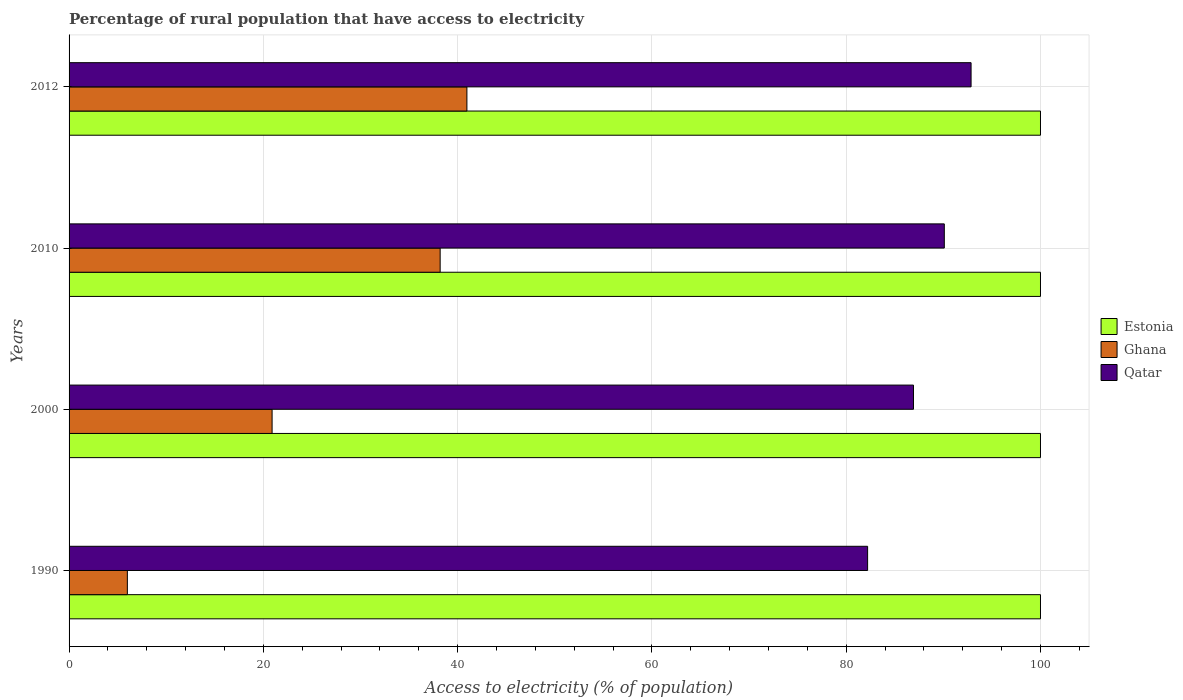How many different coloured bars are there?
Ensure brevity in your answer.  3. Are the number of bars on each tick of the Y-axis equal?
Your response must be concise. Yes. What is the percentage of rural population that have access to electricity in Ghana in 2012?
Provide a succinct answer. 40.95. Across all years, what is the maximum percentage of rural population that have access to electricity in Qatar?
Offer a very short reply. 92.85. What is the total percentage of rural population that have access to electricity in Estonia in the graph?
Offer a very short reply. 400. What is the difference between the percentage of rural population that have access to electricity in Estonia in 2010 and that in 2012?
Ensure brevity in your answer.  0. What is the difference between the percentage of rural population that have access to electricity in Ghana in 1990 and the percentage of rural population that have access to electricity in Estonia in 2000?
Your answer should be compact. -94. What is the average percentage of rural population that have access to electricity in Ghana per year?
Give a very brief answer. 26.51. In the year 1990, what is the difference between the percentage of rural population that have access to electricity in Ghana and percentage of rural population that have access to electricity in Qatar?
Your response must be concise. -76.2. In how many years, is the percentage of rural population that have access to electricity in Estonia greater than 92 %?
Ensure brevity in your answer.  4. What is the ratio of the percentage of rural population that have access to electricity in Qatar in 1990 to that in 2012?
Your answer should be compact. 0.89. Is the difference between the percentage of rural population that have access to electricity in Ghana in 1990 and 2000 greater than the difference between the percentage of rural population that have access to electricity in Qatar in 1990 and 2000?
Make the answer very short. No. What is the difference between the highest and the second highest percentage of rural population that have access to electricity in Qatar?
Keep it short and to the point. 2.75. What is the difference between the highest and the lowest percentage of rural population that have access to electricity in Qatar?
Give a very brief answer. 10.65. What does the 1st bar from the top in 2012 represents?
Your response must be concise. Qatar. What does the 1st bar from the bottom in 2010 represents?
Keep it short and to the point. Estonia. Is it the case that in every year, the sum of the percentage of rural population that have access to electricity in Estonia and percentage of rural population that have access to electricity in Ghana is greater than the percentage of rural population that have access to electricity in Qatar?
Give a very brief answer. Yes. What is the difference between two consecutive major ticks on the X-axis?
Give a very brief answer. 20. Are the values on the major ticks of X-axis written in scientific E-notation?
Provide a succinct answer. No. Does the graph contain any zero values?
Your answer should be very brief. No. Where does the legend appear in the graph?
Your response must be concise. Center right. What is the title of the graph?
Your response must be concise. Percentage of rural population that have access to electricity. Does "Isle of Man" appear as one of the legend labels in the graph?
Keep it short and to the point. No. What is the label or title of the X-axis?
Your response must be concise. Access to electricity (% of population). What is the label or title of the Y-axis?
Your answer should be very brief. Years. What is the Access to electricity (% of population) of Estonia in 1990?
Make the answer very short. 100. What is the Access to electricity (% of population) of Qatar in 1990?
Give a very brief answer. 82.2. What is the Access to electricity (% of population) in Estonia in 2000?
Give a very brief answer. 100. What is the Access to electricity (% of population) in Ghana in 2000?
Give a very brief answer. 20.9. What is the Access to electricity (% of population) in Qatar in 2000?
Your answer should be compact. 86.93. What is the Access to electricity (% of population) in Ghana in 2010?
Make the answer very short. 38.2. What is the Access to electricity (% of population) of Qatar in 2010?
Provide a succinct answer. 90.1. What is the Access to electricity (% of population) of Estonia in 2012?
Your answer should be very brief. 100. What is the Access to electricity (% of population) of Ghana in 2012?
Your answer should be compact. 40.95. What is the Access to electricity (% of population) in Qatar in 2012?
Give a very brief answer. 92.85. Across all years, what is the maximum Access to electricity (% of population) in Ghana?
Provide a short and direct response. 40.95. Across all years, what is the maximum Access to electricity (% of population) of Qatar?
Keep it short and to the point. 92.85. Across all years, what is the minimum Access to electricity (% of population) in Qatar?
Make the answer very short. 82.2. What is the total Access to electricity (% of population) in Ghana in the graph?
Offer a very short reply. 106.05. What is the total Access to electricity (% of population) in Qatar in the graph?
Offer a very short reply. 352.08. What is the difference between the Access to electricity (% of population) in Estonia in 1990 and that in 2000?
Your answer should be compact. 0. What is the difference between the Access to electricity (% of population) of Ghana in 1990 and that in 2000?
Give a very brief answer. -14.9. What is the difference between the Access to electricity (% of population) of Qatar in 1990 and that in 2000?
Offer a very short reply. -4.72. What is the difference between the Access to electricity (% of population) of Ghana in 1990 and that in 2010?
Keep it short and to the point. -32.2. What is the difference between the Access to electricity (% of population) of Qatar in 1990 and that in 2010?
Your answer should be very brief. -7.9. What is the difference between the Access to electricity (% of population) of Ghana in 1990 and that in 2012?
Ensure brevity in your answer.  -34.95. What is the difference between the Access to electricity (% of population) of Qatar in 1990 and that in 2012?
Your response must be concise. -10.65. What is the difference between the Access to electricity (% of population) of Estonia in 2000 and that in 2010?
Provide a succinct answer. 0. What is the difference between the Access to electricity (% of population) of Ghana in 2000 and that in 2010?
Provide a short and direct response. -17.3. What is the difference between the Access to electricity (% of population) in Qatar in 2000 and that in 2010?
Offer a very short reply. -3.17. What is the difference between the Access to electricity (% of population) of Estonia in 2000 and that in 2012?
Offer a very short reply. 0. What is the difference between the Access to electricity (% of population) in Ghana in 2000 and that in 2012?
Offer a terse response. -20.05. What is the difference between the Access to electricity (% of population) in Qatar in 2000 and that in 2012?
Your answer should be very brief. -5.93. What is the difference between the Access to electricity (% of population) of Estonia in 2010 and that in 2012?
Your response must be concise. 0. What is the difference between the Access to electricity (% of population) of Ghana in 2010 and that in 2012?
Your response must be concise. -2.75. What is the difference between the Access to electricity (% of population) in Qatar in 2010 and that in 2012?
Make the answer very short. -2.75. What is the difference between the Access to electricity (% of population) in Estonia in 1990 and the Access to electricity (% of population) in Ghana in 2000?
Offer a very short reply. 79.1. What is the difference between the Access to electricity (% of population) in Estonia in 1990 and the Access to electricity (% of population) in Qatar in 2000?
Provide a succinct answer. 13.07. What is the difference between the Access to electricity (% of population) of Ghana in 1990 and the Access to electricity (% of population) of Qatar in 2000?
Provide a succinct answer. -80.93. What is the difference between the Access to electricity (% of population) in Estonia in 1990 and the Access to electricity (% of population) in Ghana in 2010?
Keep it short and to the point. 61.8. What is the difference between the Access to electricity (% of population) of Estonia in 1990 and the Access to electricity (% of population) of Qatar in 2010?
Provide a succinct answer. 9.9. What is the difference between the Access to electricity (% of population) of Ghana in 1990 and the Access to electricity (% of population) of Qatar in 2010?
Your answer should be very brief. -84.1. What is the difference between the Access to electricity (% of population) in Estonia in 1990 and the Access to electricity (% of population) in Ghana in 2012?
Your answer should be compact. 59.05. What is the difference between the Access to electricity (% of population) in Estonia in 1990 and the Access to electricity (% of population) in Qatar in 2012?
Offer a terse response. 7.15. What is the difference between the Access to electricity (% of population) of Ghana in 1990 and the Access to electricity (% of population) of Qatar in 2012?
Provide a succinct answer. -86.85. What is the difference between the Access to electricity (% of population) in Estonia in 2000 and the Access to electricity (% of population) in Ghana in 2010?
Make the answer very short. 61.8. What is the difference between the Access to electricity (% of population) of Ghana in 2000 and the Access to electricity (% of population) of Qatar in 2010?
Offer a terse response. -69.2. What is the difference between the Access to electricity (% of population) of Estonia in 2000 and the Access to electricity (% of population) of Ghana in 2012?
Your answer should be compact. 59.05. What is the difference between the Access to electricity (% of population) of Estonia in 2000 and the Access to electricity (% of population) of Qatar in 2012?
Provide a succinct answer. 7.15. What is the difference between the Access to electricity (% of population) in Ghana in 2000 and the Access to electricity (% of population) in Qatar in 2012?
Offer a terse response. -71.95. What is the difference between the Access to electricity (% of population) in Estonia in 2010 and the Access to electricity (% of population) in Ghana in 2012?
Offer a very short reply. 59.05. What is the difference between the Access to electricity (% of population) of Estonia in 2010 and the Access to electricity (% of population) of Qatar in 2012?
Keep it short and to the point. 7.15. What is the difference between the Access to electricity (% of population) of Ghana in 2010 and the Access to electricity (% of population) of Qatar in 2012?
Your response must be concise. -54.65. What is the average Access to electricity (% of population) of Ghana per year?
Your response must be concise. 26.51. What is the average Access to electricity (% of population) in Qatar per year?
Your answer should be very brief. 88.02. In the year 1990, what is the difference between the Access to electricity (% of population) of Estonia and Access to electricity (% of population) of Ghana?
Ensure brevity in your answer.  94. In the year 1990, what is the difference between the Access to electricity (% of population) of Estonia and Access to electricity (% of population) of Qatar?
Make the answer very short. 17.8. In the year 1990, what is the difference between the Access to electricity (% of population) of Ghana and Access to electricity (% of population) of Qatar?
Offer a terse response. -76.2. In the year 2000, what is the difference between the Access to electricity (% of population) of Estonia and Access to electricity (% of population) of Ghana?
Give a very brief answer. 79.1. In the year 2000, what is the difference between the Access to electricity (% of population) in Estonia and Access to electricity (% of population) in Qatar?
Keep it short and to the point. 13.07. In the year 2000, what is the difference between the Access to electricity (% of population) of Ghana and Access to electricity (% of population) of Qatar?
Provide a short and direct response. -66.03. In the year 2010, what is the difference between the Access to electricity (% of population) in Estonia and Access to electricity (% of population) in Ghana?
Ensure brevity in your answer.  61.8. In the year 2010, what is the difference between the Access to electricity (% of population) in Ghana and Access to electricity (% of population) in Qatar?
Give a very brief answer. -51.9. In the year 2012, what is the difference between the Access to electricity (% of population) in Estonia and Access to electricity (% of population) in Ghana?
Your answer should be compact. 59.05. In the year 2012, what is the difference between the Access to electricity (% of population) in Estonia and Access to electricity (% of population) in Qatar?
Keep it short and to the point. 7.15. In the year 2012, what is the difference between the Access to electricity (% of population) of Ghana and Access to electricity (% of population) of Qatar?
Provide a short and direct response. -51.9. What is the ratio of the Access to electricity (% of population) in Ghana in 1990 to that in 2000?
Offer a very short reply. 0.29. What is the ratio of the Access to electricity (% of population) of Qatar in 1990 to that in 2000?
Provide a short and direct response. 0.95. What is the ratio of the Access to electricity (% of population) of Estonia in 1990 to that in 2010?
Give a very brief answer. 1. What is the ratio of the Access to electricity (% of population) in Ghana in 1990 to that in 2010?
Keep it short and to the point. 0.16. What is the ratio of the Access to electricity (% of population) of Qatar in 1990 to that in 2010?
Keep it short and to the point. 0.91. What is the ratio of the Access to electricity (% of population) in Ghana in 1990 to that in 2012?
Provide a succinct answer. 0.15. What is the ratio of the Access to electricity (% of population) of Qatar in 1990 to that in 2012?
Offer a very short reply. 0.89. What is the ratio of the Access to electricity (% of population) in Estonia in 2000 to that in 2010?
Make the answer very short. 1. What is the ratio of the Access to electricity (% of population) in Ghana in 2000 to that in 2010?
Make the answer very short. 0.55. What is the ratio of the Access to electricity (% of population) in Qatar in 2000 to that in 2010?
Ensure brevity in your answer.  0.96. What is the ratio of the Access to electricity (% of population) of Ghana in 2000 to that in 2012?
Offer a very short reply. 0.51. What is the ratio of the Access to electricity (% of population) in Qatar in 2000 to that in 2012?
Make the answer very short. 0.94. What is the ratio of the Access to electricity (% of population) in Estonia in 2010 to that in 2012?
Provide a short and direct response. 1. What is the ratio of the Access to electricity (% of population) of Ghana in 2010 to that in 2012?
Ensure brevity in your answer.  0.93. What is the ratio of the Access to electricity (% of population) in Qatar in 2010 to that in 2012?
Make the answer very short. 0.97. What is the difference between the highest and the second highest Access to electricity (% of population) of Estonia?
Your response must be concise. 0. What is the difference between the highest and the second highest Access to electricity (% of population) in Ghana?
Your response must be concise. 2.75. What is the difference between the highest and the second highest Access to electricity (% of population) of Qatar?
Your response must be concise. 2.75. What is the difference between the highest and the lowest Access to electricity (% of population) of Estonia?
Provide a succinct answer. 0. What is the difference between the highest and the lowest Access to electricity (% of population) in Ghana?
Provide a short and direct response. 34.95. What is the difference between the highest and the lowest Access to electricity (% of population) of Qatar?
Provide a succinct answer. 10.65. 